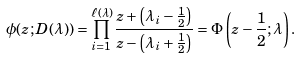Convert formula to latex. <formula><loc_0><loc_0><loc_500><loc_500>\phi ( z ; D ( \lambda ) ) = \prod _ { i = 1 } ^ { \ell ( \lambda ) } \frac { z + \left ( \lambda _ { i } - \frac { 1 } { 2 } \right ) } { z - \left ( \lambda _ { i } + \frac { 1 } { 2 } \right ) } = \Phi \left ( z - \frac { 1 } { 2 } ; \lambda \right ) .</formula> 